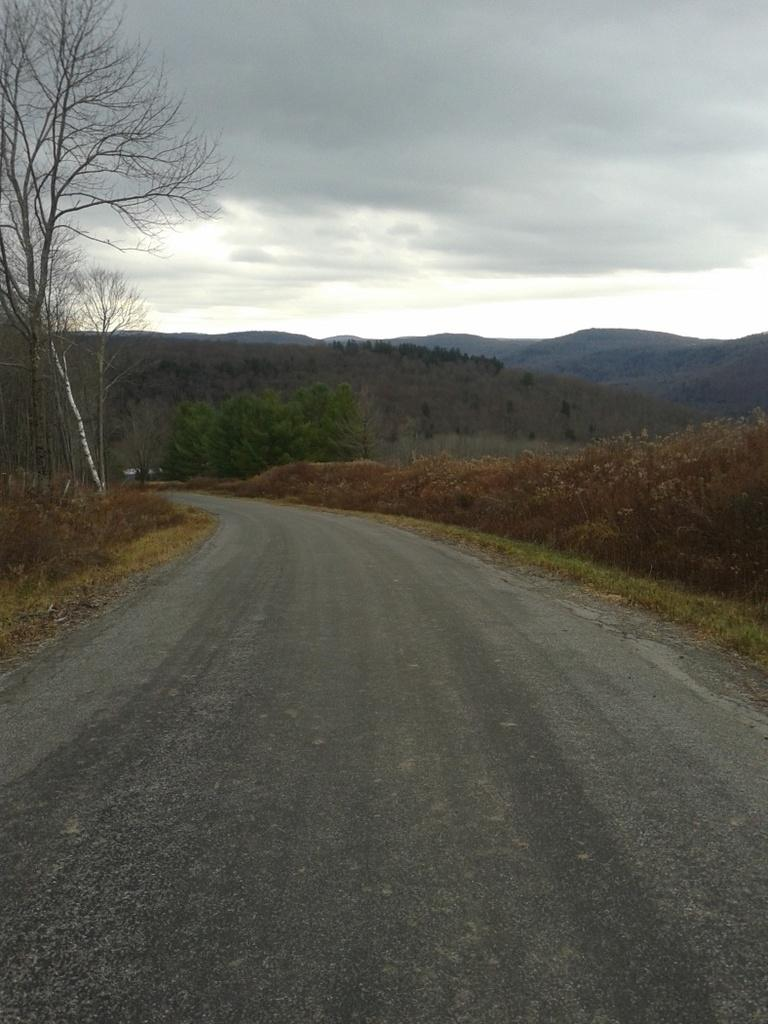What is the main feature of the image? There is a road in the image. What can be seen alongside the road? Plants and grass are present on both sides of the road. What is visible in the background of the image? There are trees in the background of the image, and they are on mountains. What is visible in the sky? Clouds are visible in the sky. What type of pancake is being served at the restaurant in the image? There is no restaurant or pancake present in the image; it features a road with plants, grass, trees, mountains, and clouds. 